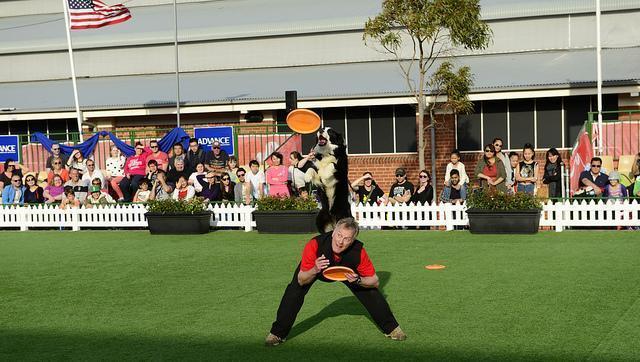How many frisbees are there?
Give a very brief answer. 3. How many people can be seen?
Give a very brief answer. 2. How many clocks are in this photo?
Give a very brief answer. 0. 